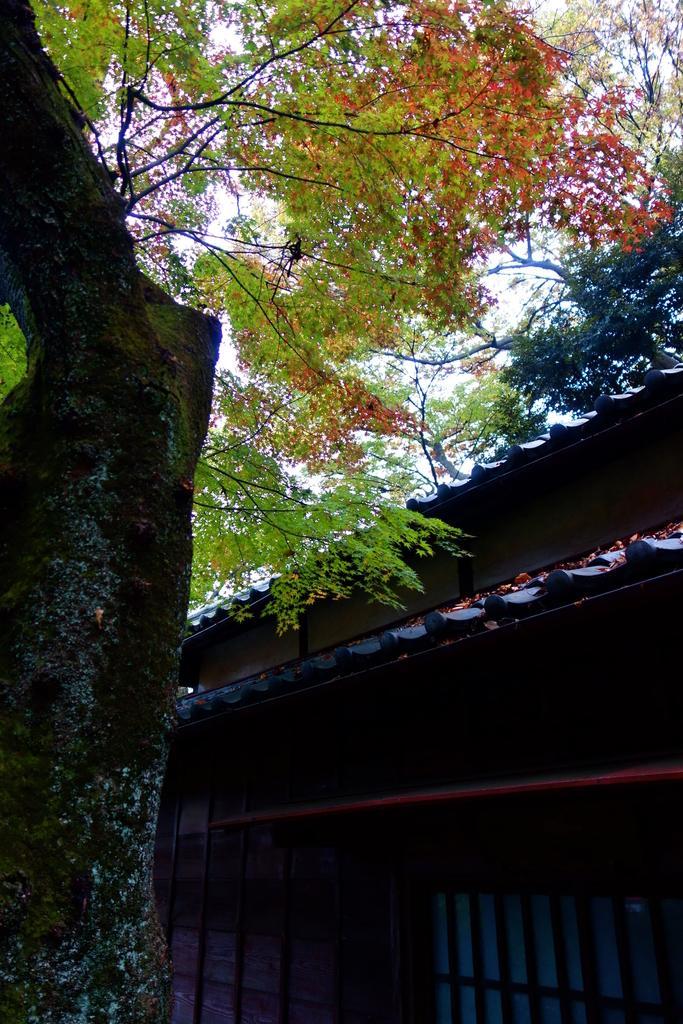Could you give a brief overview of what you see in this image? In this picture there is a tree towards the left. At the bottom right there is a house. 